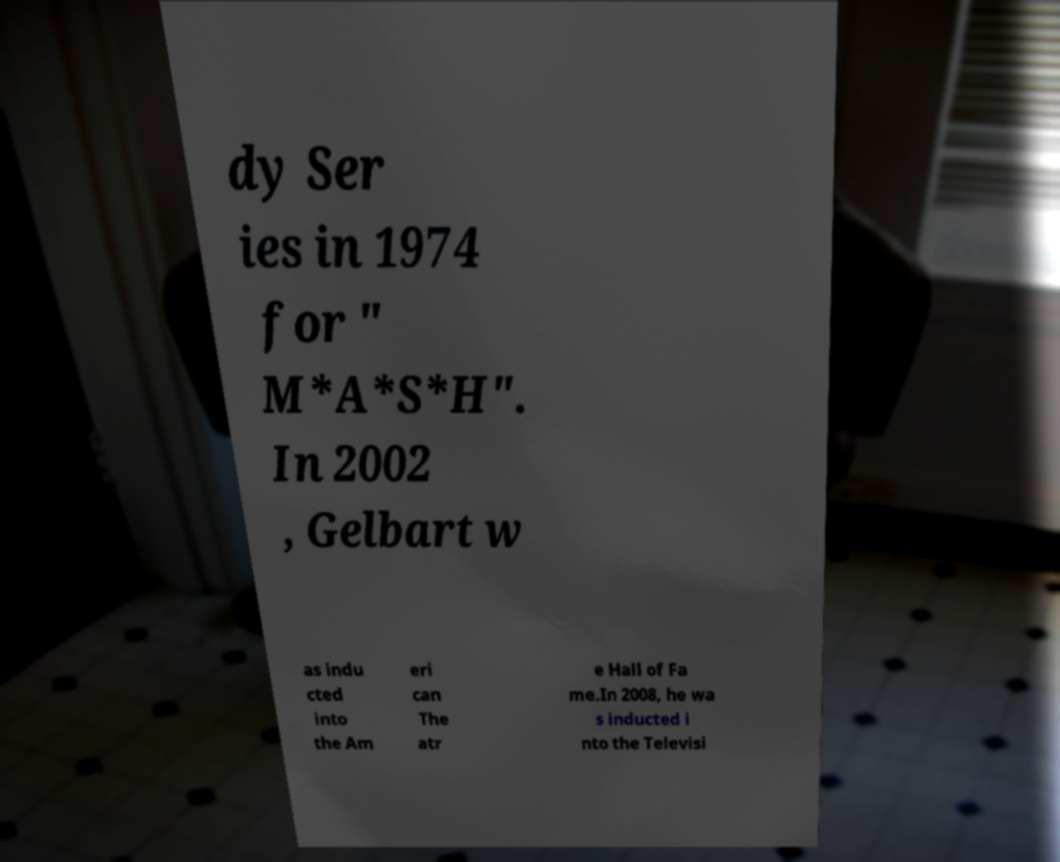Can you accurately transcribe the text from the provided image for me? dy Ser ies in 1974 for " M*A*S*H". In 2002 , Gelbart w as indu cted into the Am eri can The atr e Hall of Fa me.In 2008, he wa s inducted i nto the Televisi 